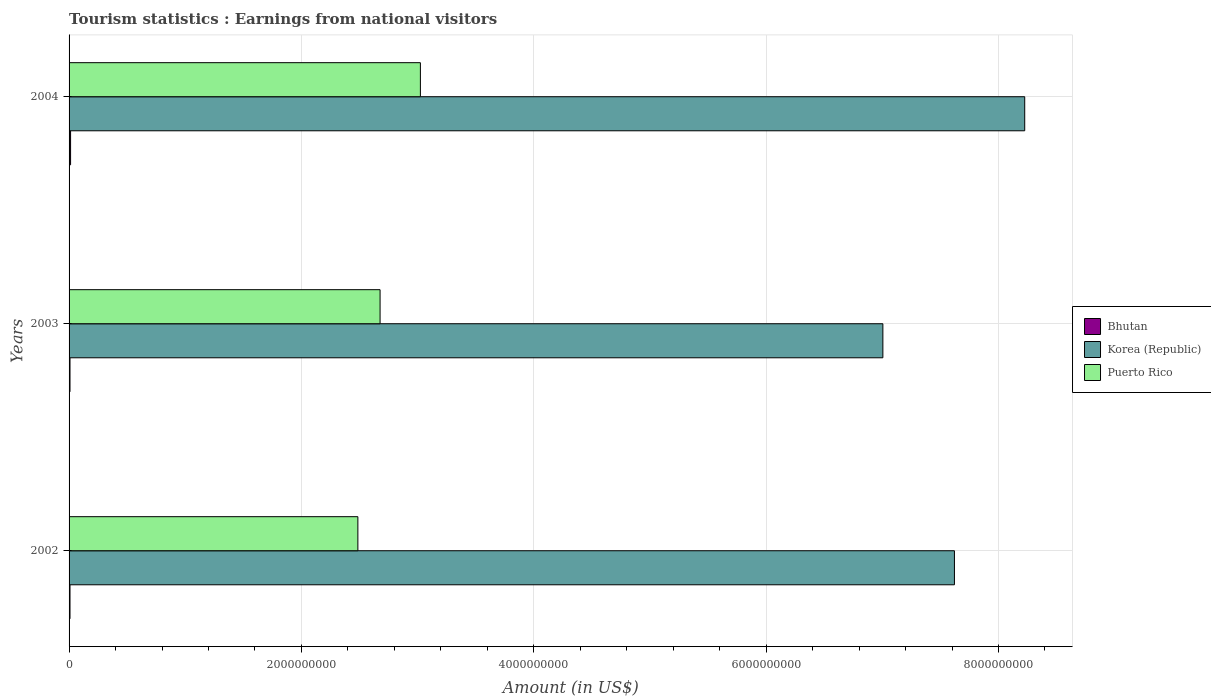How many different coloured bars are there?
Offer a terse response. 3. Are the number of bars per tick equal to the number of legend labels?
Provide a succinct answer. Yes. What is the earnings from national visitors in Bhutan in 2002?
Your response must be concise. 8.00e+06. Across all years, what is the maximum earnings from national visitors in Korea (Republic)?
Make the answer very short. 8.23e+09. Across all years, what is the minimum earnings from national visitors in Bhutan?
Give a very brief answer. 8.00e+06. In which year was the earnings from national visitors in Bhutan maximum?
Offer a very short reply. 2004. In which year was the earnings from national visitors in Bhutan minimum?
Offer a very short reply. 2002. What is the total earnings from national visitors in Bhutan in the graph?
Offer a very short reply. 2.90e+07. What is the difference between the earnings from national visitors in Korea (Republic) in 2002 and that in 2003?
Your answer should be compact. 6.16e+08. What is the difference between the earnings from national visitors in Bhutan in 2003 and the earnings from national visitors in Korea (Republic) in 2002?
Your answer should be very brief. -7.61e+09. What is the average earnings from national visitors in Korea (Republic) per year?
Offer a terse response. 7.62e+09. In the year 2004, what is the difference between the earnings from national visitors in Puerto Rico and earnings from national visitors in Bhutan?
Provide a short and direct response. 3.01e+09. What is the ratio of the earnings from national visitors in Korea (Republic) in 2002 to that in 2004?
Your response must be concise. 0.93. What is the difference between the highest and the second highest earnings from national visitors in Puerto Rico?
Provide a short and direct response. 3.47e+08. What is the difference between the highest and the lowest earnings from national visitors in Korea (Republic)?
Ensure brevity in your answer.  1.22e+09. In how many years, is the earnings from national visitors in Bhutan greater than the average earnings from national visitors in Bhutan taken over all years?
Provide a short and direct response. 1. What does the 3rd bar from the top in 2004 represents?
Your response must be concise. Bhutan. Is it the case that in every year, the sum of the earnings from national visitors in Puerto Rico and earnings from national visitors in Bhutan is greater than the earnings from national visitors in Korea (Republic)?
Make the answer very short. No. How many bars are there?
Ensure brevity in your answer.  9. Are all the bars in the graph horizontal?
Keep it short and to the point. Yes. How many years are there in the graph?
Offer a terse response. 3. What is the difference between two consecutive major ticks on the X-axis?
Offer a very short reply. 2.00e+09. Are the values on the major ticks of X-axis written in scientific E-notation?
Ensure brevity in your answer.  No. Does the graph contain any zero values?
Make the answer very short. No. Does the graph contain grids?
Your answer should be compact. Yes. Where does the legend appear in the graph?
Your answer should be very brief. Center right. How are the legend labels stacked?
Make the answer very short. Vertical. What is the title of the graph?
Your response must be concise. Tourism statistics : Earnings from national visitors. Does "Afghanistan" appear as one of the legend labels in the graph?
Provide a short and direct response. No. What is the label or title of the X-axis?
Make the answer very short. Amount (in US$). What is the Amount (in US$) in Bhutan in 2002?
Provide a succinct answer. 8.00e+06. What is the Amount (in US$) in Korea (Republic) in 2002?
Provide a short and direct response. 7.62e+09. What is the Amount (in US$) in Puerto Rico in 2002?
Your answer should be compact. 2.49e+09. What is the Amount (in US$) of Bhutan in 2003?
Provide a succinct answer. 8.00e+06. What is the Amount (in US$) in Korea (Republic) in 2003?
Your response must be concise. 7.00e+09. What is the Amount (in US$) of Puerto Rico in 2003?
Keep it short and to the point. 2.68e+09. What is the Amount (in US$) in Bhutan in 2004?
Offer a terse response. 1.30e+07. What is the Amount (in US$) of Korea (Republic) in 2004?
Your answer should be very brief. 8.23e+09. What is the Amount (in US$) of Puerto Rico in 2004?
Keep it short and to the point. 3.02e+09. Across all years, what is the maximum Amount (in US$) of Bhutan?
Your response must be concise. 1.30e+07. Across all years, what is the maximum Amount (in US$) of Korea (Republic)?
Your answer should be compact. 8.23e+09. Across all years, what is the maximum Amount (in US$) of Puerto Rico?
Make the answer very short. 3.02e+09. Across all years, what is the minimum Amount (in US$) in Bhutan?
Provide a short and direct response. 8.00e+06. Across all years, what is the minimum Amount (in US$) of Korea (Republic)?
Your answer should be very brief. 7.00e+09. Across all years, what is the minimum Amount (in US$) in Puerto Rico?
Offer a terse response. 2.49e+09. What is the total Amount (in US$) of Bhutan in the graph?
Offer a very short reply. 2.90e+07. What is the total Amount (in US$) of Korea (Republic) in the graph?
Your answer should be compact. 2.29e+1. What is the total Amount (in US$) in Puerto Rico in the graph?
Offer a terse response. 8.19e+09. What is the difference between the Amount (in US$) in Korea (Republic) in 2002 and that in 2003?
Your answer should be very brief. 6.16e+08. What is the difference between the Amount (in US$) in Puerto Rico in 2002 and that in 2003?
Provide a short and direct response. -1.91e+08. What is the difference between the Amount (in US$) of Bhutan in 2002 and that in 2004?
Your answer should be very brief. -5.00e+06. What is the difference between the Amount (in US$) of Korea (Republic) in 2002 and that in 2004?
Your answer should be very brief. -6.05e+08. What is the difference between the Amount (in US$) of Puerto Rico in 2002 and that in 2004?
Your answer should be very brief. -5.38e+08. What is the difference between the Amount (in US$) in Bhutan in 2003 and that in 2004?
Your answer should be compact. -5.00e+06. What is the difference between the Amount (in US$) of Korea (Republic) in 2003 and that in 2004?
Offer a very short reply. -1.22e+09. What is the difference between the Amount (in US$) of Puerto Rico in 2003 and that in 2004?
Your response must be concise. -3.47e+08. What is the difference between the Amount (in US$) in Bhutan in 2002 and the Amount (in US$) in Korea (Republic) in 2003?
Ensure brevity in your answer.  -7.00e+09. What is the difference between the Amount (in US$) of Bhutan in 2002 and the Amount (in US$) of Puerto Rico in 2003?
Provide a short and direct response. -2.67e+09. What is the difference between the Amount (in US$) of Korea (Republic) in 2002 and the Amount (in US$) of Puerto Rico in 2003?
Make the answer very short. 4.94e+09. What is the difference between the Amount (in US$) in Bhutan in 2002 and the Amount (in US$) in Korea (Republic) in 2004?
Offer a terse response. -8.22e+09. What is the difference between the Amount (in US$) in Bhutan in 2002 and the Amount (in US$) in Puerto Rico in 2004?
Provide a succinct answer. -3.02e+09. What is the difference between the Amount (in US$) of Korea (Republic) in 2002 and the Amount (in US$) of Puerto Rico in 2004?
Your answer should be very brief. 4.60e+09. What is the difference between the Amount (in US$) of Bhutan in 2003 and the Amount (in US$) of Korea (Republic) in 2004?
Make the answer very short. -8.22e+09. What is the difference between the Amount (in US$) in Bhutan in 2003 and the Amount (in US$) in Puerto Rico in 2004?
Your answer should be compact. -3.02e+09. What is the difference between the Amount (in US$) in Korea (Republic) in 2003 and the Amount (in US$) in Puerto Rico in 2004?
Provide a short and direct response. 3.98e+09. What is the average Amount (in US$) in Bhutan per year?
Your response must be concise. 9.67e+06. What is the average Amount (in US$) of Korea (Republic) per year?
Provide a succinct answer. 7.62e+09. What is the average Amount (in US$) in Puerto Rico per year?
Provide a short and direct response. 2.73e+09. In the year 2002, what is the difference between the Amount (in US$) of Bhutan and Amount (in US$) of Korea (Republic)?
Provide a short and direct response. -7.61e+09. In the year 2002, what is the difference between the Amount (in US$) in Bhutan and Amount (in US$) in Puerto Rico?
Your response must be concise. -2.48e+09. In the year 2002, what is the difference between the Amount (in US$) in Korea (Republic) and Amount (in US$) in Puerto Rico?
Make the answer very short. 5.14e+09. In the year 2003, what is the difference between the Amount (in US$) in Bhutan and Amount (in US$) in Korea (Republic)?
Ensure brevity in your answer.  -7.00e+09. In the year 2003, what is the difference between the Amount (in US$) of Bhutan and Amount (in US$) of Puerto Rico?
Offer a very short reply. -2.67e+09. In the year 2003, what is the difference between the Amount (in US$) of Korea (Republic) and Amount (in US$) of Puerto Rico?
Provide a short and direct response. 4.33e+09. In the year 2004, what is the difference between the Amount (in US$) in Bhutan and Amount (in US$) in Korea (Republic)?
Give a very brief answer. -8.21e+09. In the year 2004, what is the difference between the Amount (in US$) in Bhutan and Amount (in US$) in Puerto Rico?
Your response must be concise. -3.01e+09. In the year 2004, what is the difference between the Amount (in US$) in Korea (Republic) and Amount (in US$) in Puerto Rico?
Offer a very short reply. 5.20e+09. What is the ratio of the Amount (in US$) of Bhutan in 2002 to that in 2003?
Your answer should be compact. 1. What is the ratio of the Amount (in US$) of Korea (Republic) in 2002 to that in 2003?
Make the answer very short. 1.09. What is the ratio of the Amount (in US$) in Puerto Rico in 2002 to that in 2003?
Offer a very short reply. 0.93. What is the ratio of the Amount (in US$) of Bhutan in 2002 to that in 2004?
Make the answer very short. 0.62. What is the ratio of the Amount (in US$) of Korea (Republic) in 2002 to that in 2004?
Give a very brief answer. 0.93. What is the ratio of the Amount (in US$) in Puerto Rico in 2002 to that in 2004?
Make the answer very short. 0.82. What is the ratio of the Amount (in US$) in Bhutan in 2003 to that in 2004?
Your answer should be compact. 0.62. What is the ratio of the Amount (in US$) of Korea (Republic) in 2003 to that in 2004?
Your response must be concise. 0.85. What is the ratio of the Amount (in US$) of Puerto Rico in 2003 to that in 2004?
Offer a very short reply. 0.89. What is the difference between the highest and the second highest Amount (in US$) of Korea (Republic)?
Your response must be concise. 6.05e+08. What is the difference between the highest and the second highest Amount (in US$) of Puerto Rico?
Your answer should be very brief. 3.47e+08. What is the difference between the highest and the lowest Amount (in US$) in Bhutan?
Give a very brief answer. 5.00e+06. What is the difference between the highest and the lowest Amount (in US$) of Korea (Republic)?
Offer a terse response. 1.22e+09. What is the difference between the highest and the lowest Amount (in US$) of Puerto Rico?
Provide a short and direct response. 5.38e+08. 